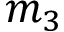<formula> <loc_0><loc_0><loc_500><loc_500>m _ { 3 }</formula> 